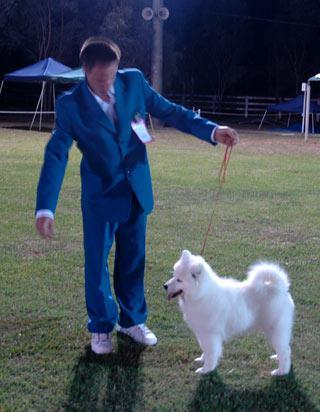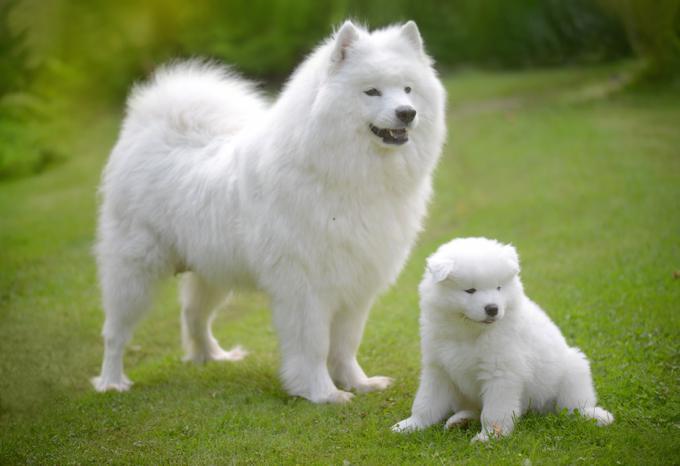The first image is the image on the left, the second image is the image on the right. Analyze the images presented: Is the assertion "An image with one dog shows a person standing outdoors next to the dog on a leash." valid? Answer yes or no. Yes. 